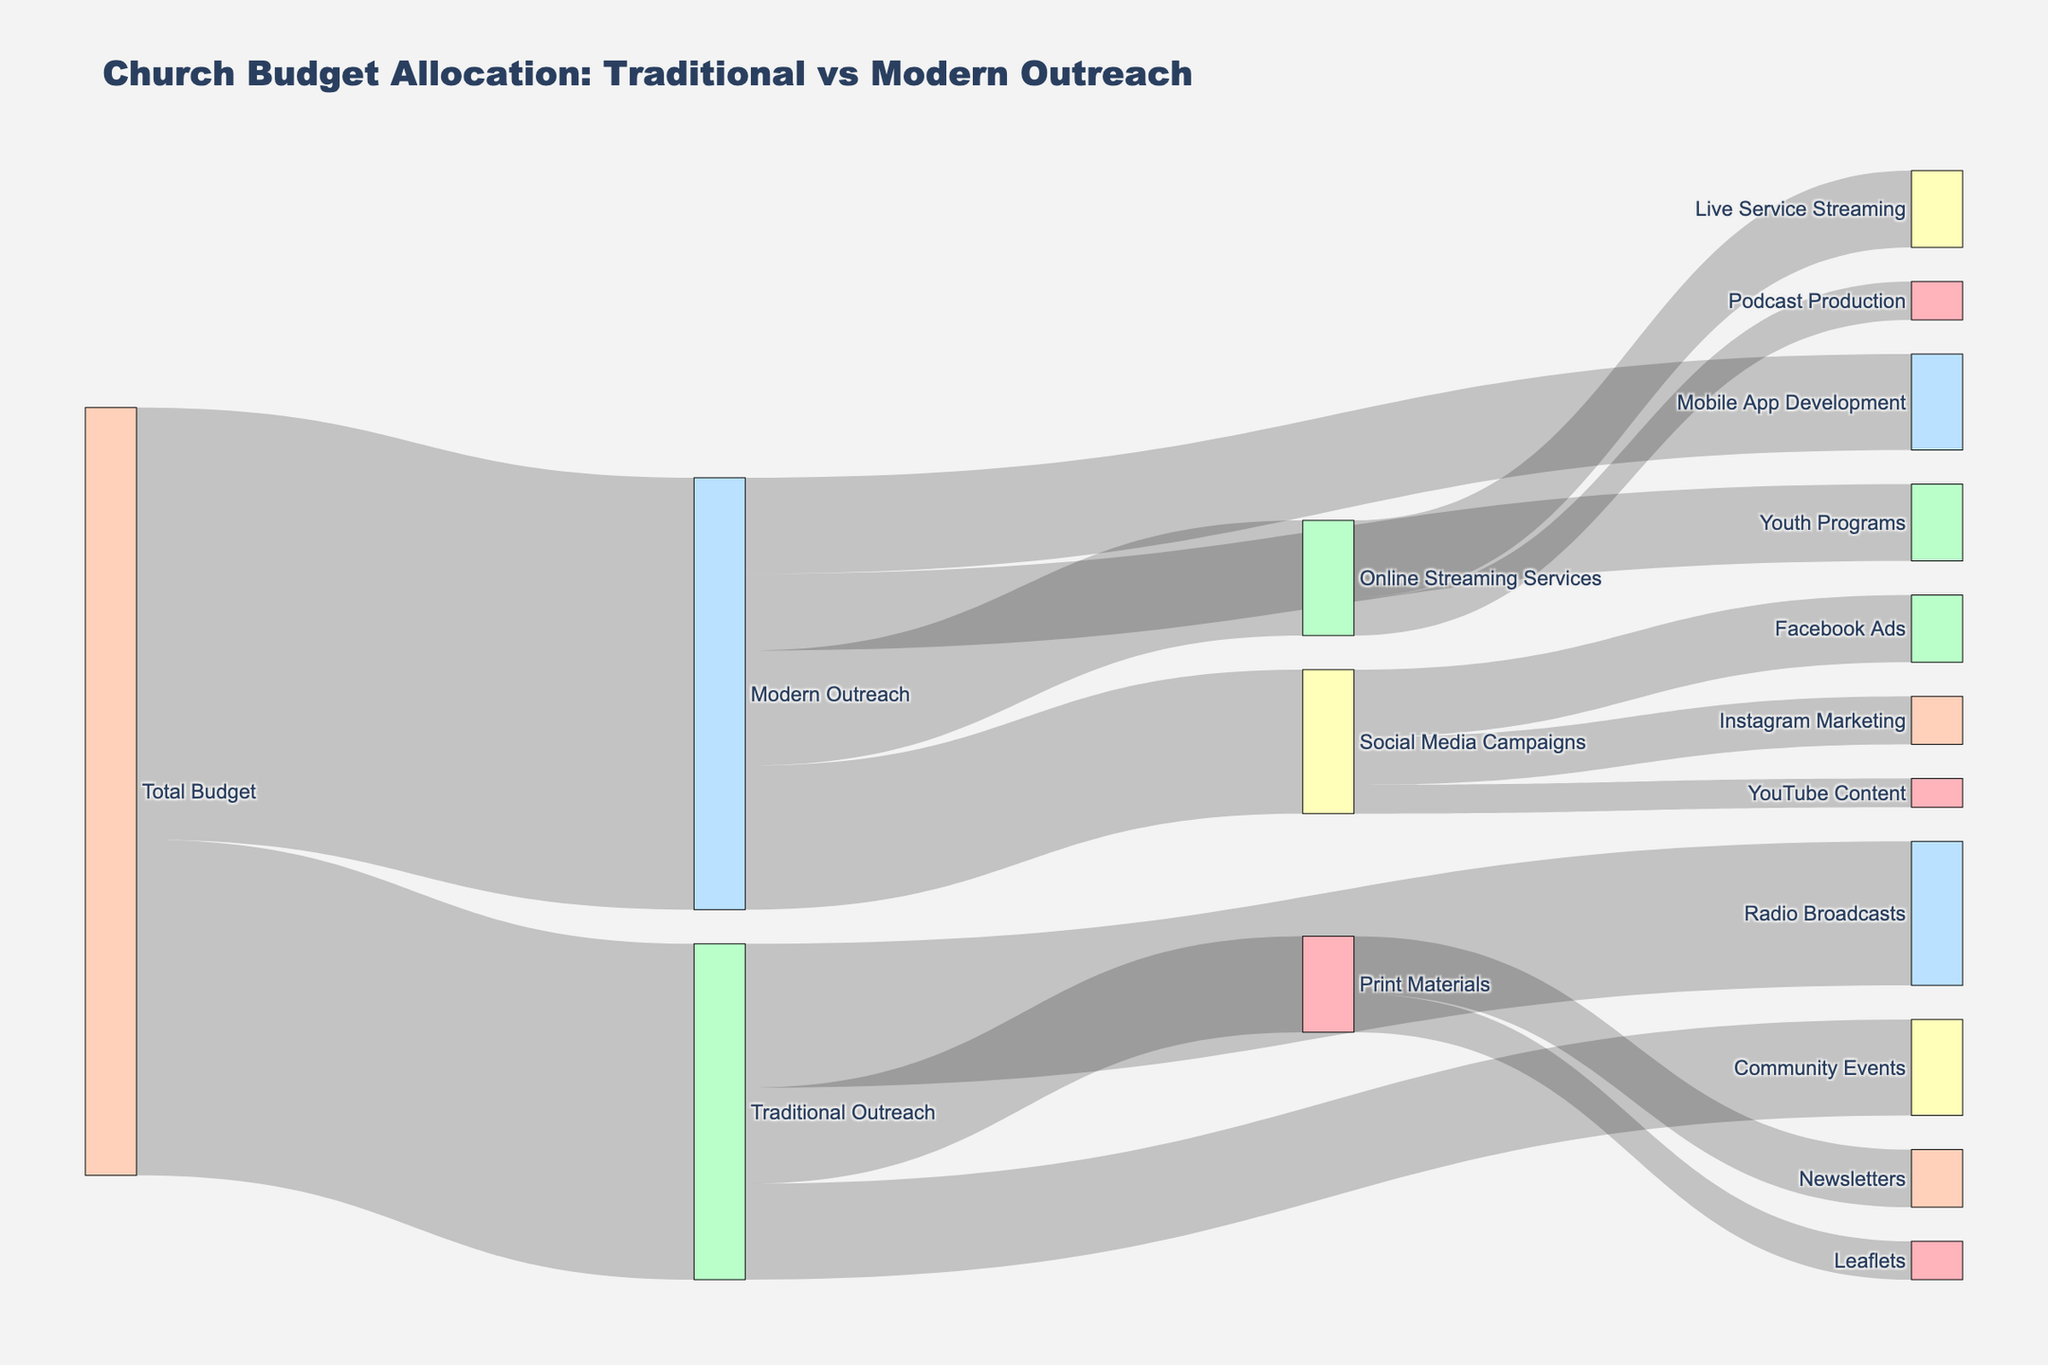How is the church budget divided between Traditional Outreach and Modern Outreach? According to the data, the total budget is divided into $350,000 for Traditional Outreach and $450,000 for Modern Outreach.
Answer: Traditional Outreach: $350,000, Modern Outreach: $450,000 Which category under Traditional Outreach receives the most funding? By looking at the figure, Radio Broadcasts under Traditional Outreach receives the most funding with an allocation of $150,000.
Answer: Radio Broadcasts: $150,000 How much of the Modern Outreach budget is allocated to Online Streaming Services? Online Streaming Services receives $120,000 from the Modern Outreach budget.
Answer: $120,000 Compare the funding for Youth Programs and Community Events. Which one gets more? Community Events receives $100,000, while Youth Programs get $80,000 from the budget. Community Events get more funding.
Answer: Community Events: $100,000, Youth Programs: $80,000 Which sub-category receives the least funding within Social Media Campaigns? Among Facebook Ads, Instagram Marketing, and YouTube Content, YouTube Content receives the least funding with $30,000.
Answer: YouTube Content: $30,000 What is the total budget allocated to Print Materials? The budget allocated to Print Materials is calculated by summing the amounts for Leaflets ($40,000) and Newsletters ($60,000), which equals $100,000.
Answer: $100,000 How does the funding for Mobile App Development compare to Radio Broadcasts? Mobile App Development receives $100,000 while Radio Broadcasts receive $150,000. Radio Broadcasts receives more funding.
Answer: Mobile App Development: $100,000, Radio Broadcasts: $150,000 Out of the total budget, how much is allocated to Leaflets and Live Service Streaming combined? Leaflets receive $40,000 and Live Service Streaming receives $80,000. Combined, they total $40,000 + $80,000 = $120,000.
Answer: $120,000 Considering both Modern and Traditional Outreach, which sub-category receives exactly $80,000? Both Live Service Streaming and Youth Programs receive exactly $80,000.
Answer: Live Service Streaming: $80,000, Youth Programs: $80,000 What percentage of the Modern Outreach budget is allocated to Social Media Campaigns? Social Media Campaigns receive $150,000 out of the total $450,000 budget for Modern Outreach. The percentage is calculated as \(\frac{150,000}{450,000} \times 100 = 33.33\%\).
Answer: 33.33% 